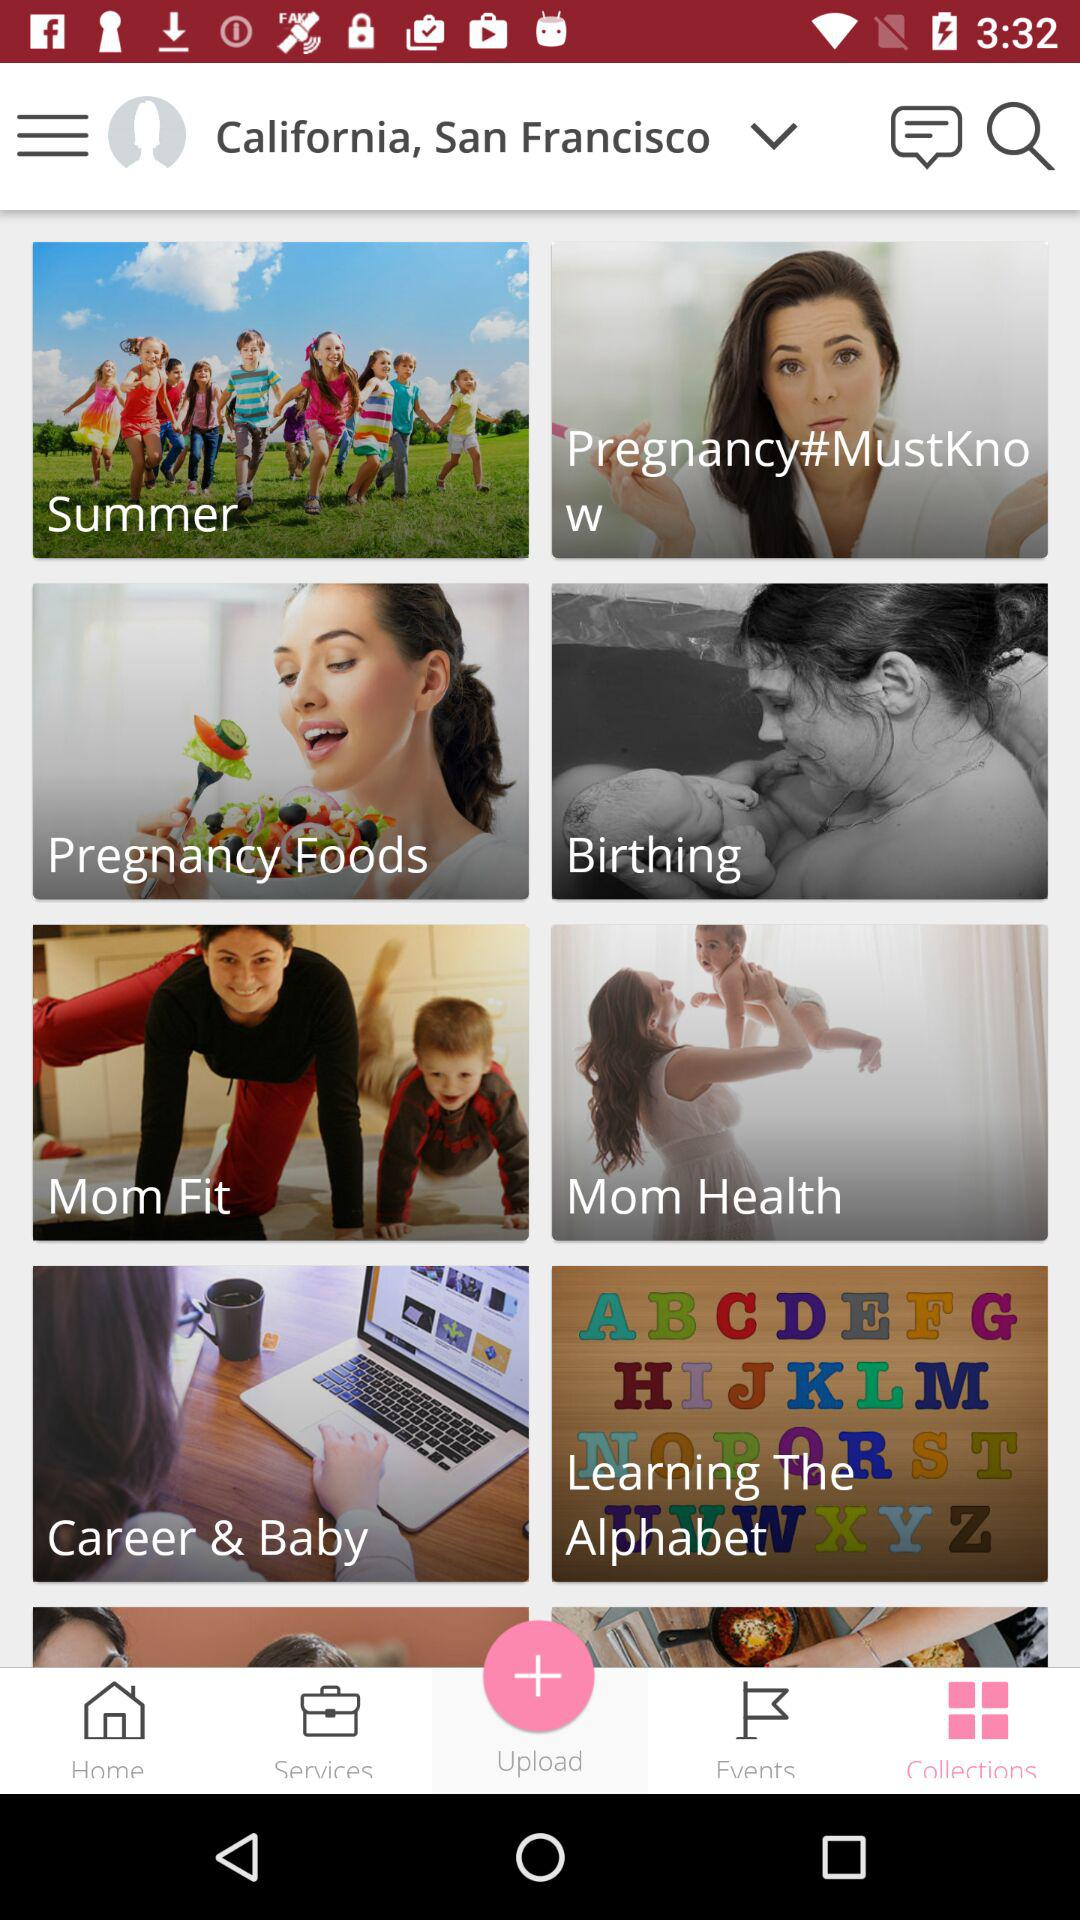What county has been selected? The country that has been selected is California, San Francisco. 